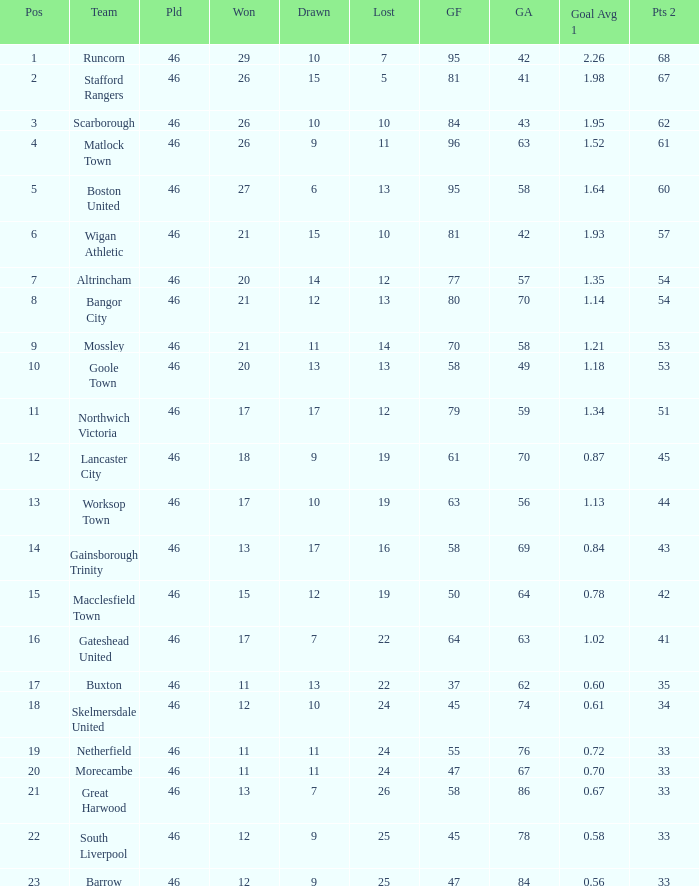Which team had goal averages of 1.34? Northwich Victoria. 